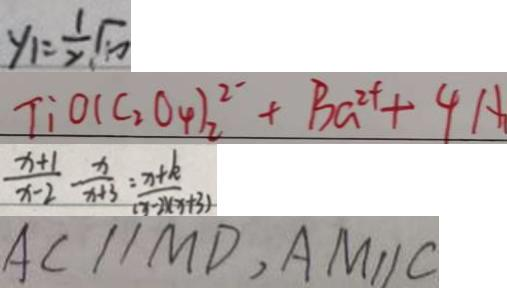<formula> <loc_0><loc_0><loc_500><loc_500>y _ { 1 } = \frac { 1 } { 2 } \sqrt { 1 0 } 
 T : o 1 ( C _ { 2 } O _ { 4 } ) _ { 2 } ^ { 2 - } + B _ { G ^ { 2 + } } + 4 A 
 \frac { x + 1 } { x - 2 } - \frac { x } { x + 3 } = \frac { x + k } { ( x - 2 x ( x + 3 ) } 
 A C / / M D , A M / / C</formula> 